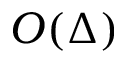<formula> <loc_0><loc_0><loc_500><loc_500>O ( \Delta )</formula> 